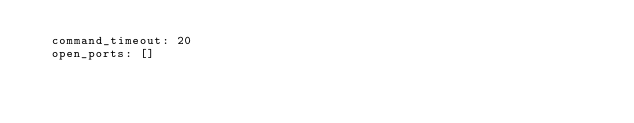<code> <loc_0><loc_0><loc_500><loc_500><_YAML_>  command_timeout: 20
  open_ports: []
</code> 